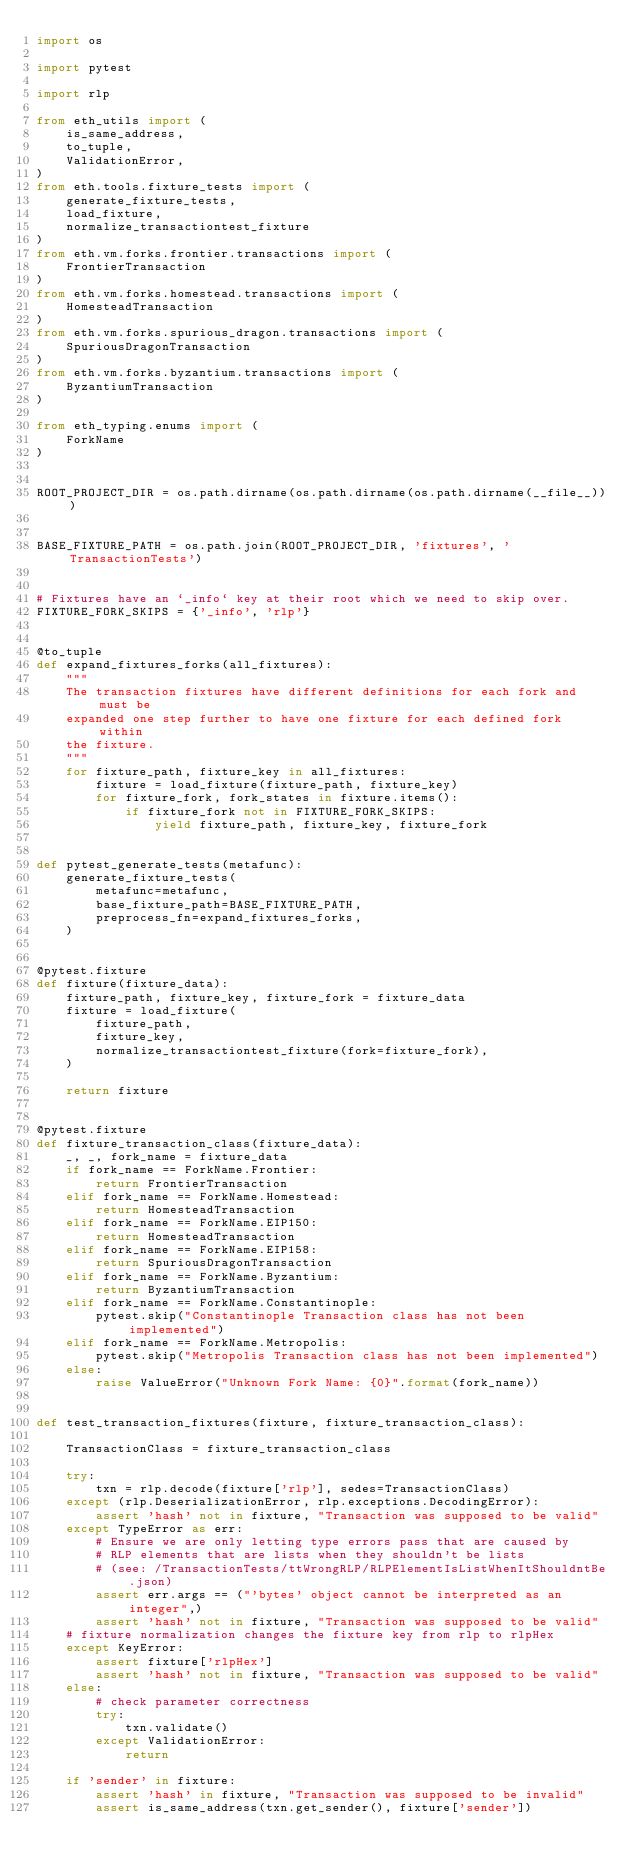Convert code to text. <code><loc_0><loc_0><loc_500><loc_500><_Python_>import os

import pytest

import rlp

from eth_utils import (
    is_same_address,
    to_tuple,
    ValidationError,
)
from eth.tools.fixture_tests import (
    generate_fixture_tests,
    load_fixture,
    normalize_transactiontest_fixture
)
from eth.vm.forks.frontier.transactions import (
    FrontierTransaction
)
from eth.vm.forks.homestead.transactions import (
    HomesteadTransaction
)
from eth.vm.forks.spurious_dragon.transactions import (
    SpuriousDragonTransaction
)
from eth.vm.forks.byzantium.transactions import (
    ByzantiumTransaction
)

from eth_typing.enums import (
    ForkName
)


ROOT_PROJECT_DIR = os.path.dirname(os.path.dirname(os.path.dirname(__file__)))


BASE_FIXTURE_PATH = os.path.join(ROOT_PROJECT_DIR, 'fixtures', 'TransactionTests')


# Fixtures have an `_info` key at their root which we need to skip over.
FIXTURE_FORK_SKIPS = {'_info', 'rlp'}


@to_tuple
def expand_fixtures_forks(all_fixtures):
    """
    The transaction fixtures have different definitions for each fork and must be
    expanded one step further to have one fixture for each defined fork within
    the fixture.
    """
    for fixture_path, fixture_key in all_fixtures:
        fixture = load_fixture(fixture_path, fixture_key)
        for fixture_fork, fork_states in fixture.items():
            if fixture_fork not in FIXTURE_FORK_SKIPS:
                yield fixture_path, fixture_key, fixture_fork


def pytest_generate_tests(metafunc):
    generate_fixture_tests(
        metafunc=metafunc,
        base_fixture_path=BASE_FIXTURE_PATH,
        preprocess_fn=expand_fixtures_forks,
    )


@pytest.fixture
def fixture(fixture_data):
    fixture_path, fixture_key, fixture_fork = fixture_data
    fixture = load_fixture(
        fixture_path,
        fixture_key,
        normalize_transactiontest_fixture(fork=fixture_fork),
    )

    return fixture


@pytest.fixture
def fixture_transaction_class(fixture_data):
    _, _, fork_name = fixture_data
    if fork_name == ForkName.Frontier:
        return FrontierTransaction
    elif fork_name == ForkName.Homestead:
        return HomesteadTransaction
    elif fork_name == ForkName.EIP150:
        return HomesteadTransaction
    elif fork_name == ForkName.EIP158:
        return SpuriousDragonTransaction
    elif fork_name == ForkName.Byzantium:
        return ByzantiumTransaction
    elif fork_name == ForkName.Constantinople:
        pytest.skip("Constantinople Transaction class has not been implemented")
    elif fork_name == ForkName.Metropolis:
        pytest.skip("Metropolis Transaction class has not been implemented")
    else:
        raise ValueError("Unknown Fork Name: {0}".format(fork_name))


def test_transaction_fixtures(fixture, fixture_transaction_class):

    TransactionClass = fixture_transaction_class

    try:
        txn = rlp.decode(fixture['rlp'], sedes=TransactionClass)
    except (rlp.DeserializationError, rlp.exceptions.DecodingError):
        assert 'hash' not in fixture, "Transaction was supposed to be valid"
    except TypeError as err:
        # Ensure we are only letting type errors pass that are caused by
        # RLP elements that are lists when they shouldn't be lists
        # (see: /TransactionTests/ttWrongRLP/RLPElementIsListWhenItShouldntBe.json)
        assert err.args == ("'bytes' object cannot be interpreted as an integer",)
        assert 'hash' not in fixture, "Transaction was supposed to be valid"
    # fixture normalization changes the fixture key from rlp to rlpHex
    except KeyError:
        assert fixture['rlpHex']
        assert 'hash' not in fixture, "Transaction was supposed to be valid"
    else:
        # check parameter correctness
        try:
            txn.validate()
        except ValidationError:
            return

    if 'sender' in fixture:
        assert 'hash' in fixture, "Transaction was supposed to be invalid"
        assert is_same_address(txn.get_sender(), fixture['sender'])
</code> 